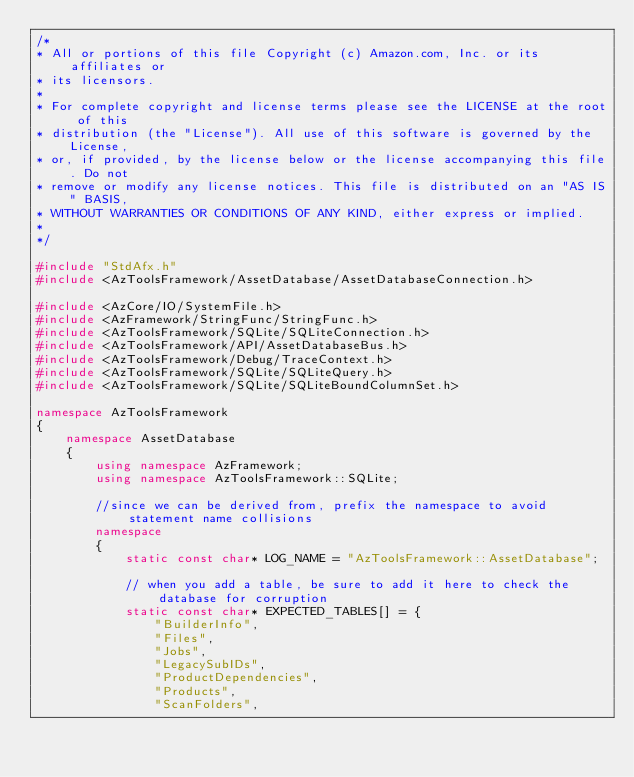<code> <loc_0><loc_0><loc_500><loc_500><_C++_>/*
* All or portions of this file Copyright (c) Amazon.com, Inc. or its affiliates or
* its licensors.
*
* For complete copyright and license terms please see the LICENSE at the root of this
* distribution (the "License"). All use of this software is governed by the License,
* or, if provided, by the license below or the license accompanying this file. Do not
* remove or modify any license notices. This file is distributed on an "AS IS" BASIS,
* WITHOUT WARRANTIES OR CONDITIONS OF ANY KIND, either express or implied.
*
*/

#include "StdAfx.h"
#include <AzToolsFramework/AssetDatabase/AssetDatabaseConnection.h>

#include <AzCore/IO/SystemFile.h>
#include <AzFramework/StringFunc/StringFunc.h>
#include <AzToolsFramework/SQLite/SQLiteConnection.h>
#include <AzToolsFramework/API/AssetDatabaseBus.h>
#include <AzToolsFramework/Debug/TraceContext.h>
#include <AzToolsFramework/SQLite/SQLiteQuery.h>
#include <AzToolsFramework/SQLite/SQLiteBoundColumnSet.h>

namespace AzToolsFramework
{
    namespace AssetDatabase
    {
        using namespace AzFramework;
        using namespace AzToolsFramework::SQLite;

        //since we can be derived from, prefix the namespace to avoid statement name collisions
        namespace
        {
            static const char* LOG_NAME = "AzToolsFramework::AssetDatabase";

            // when you add a table, be sure to add it here to check the database for corruption
            static const char* EXPECTED_TABLES[] = {
                "BuilderInfo",
                "Files",
                "Jobs",
                "LegacySubIDs",
                "ProductDependencies",
                "Products",
                "ScanFolders",</code> 